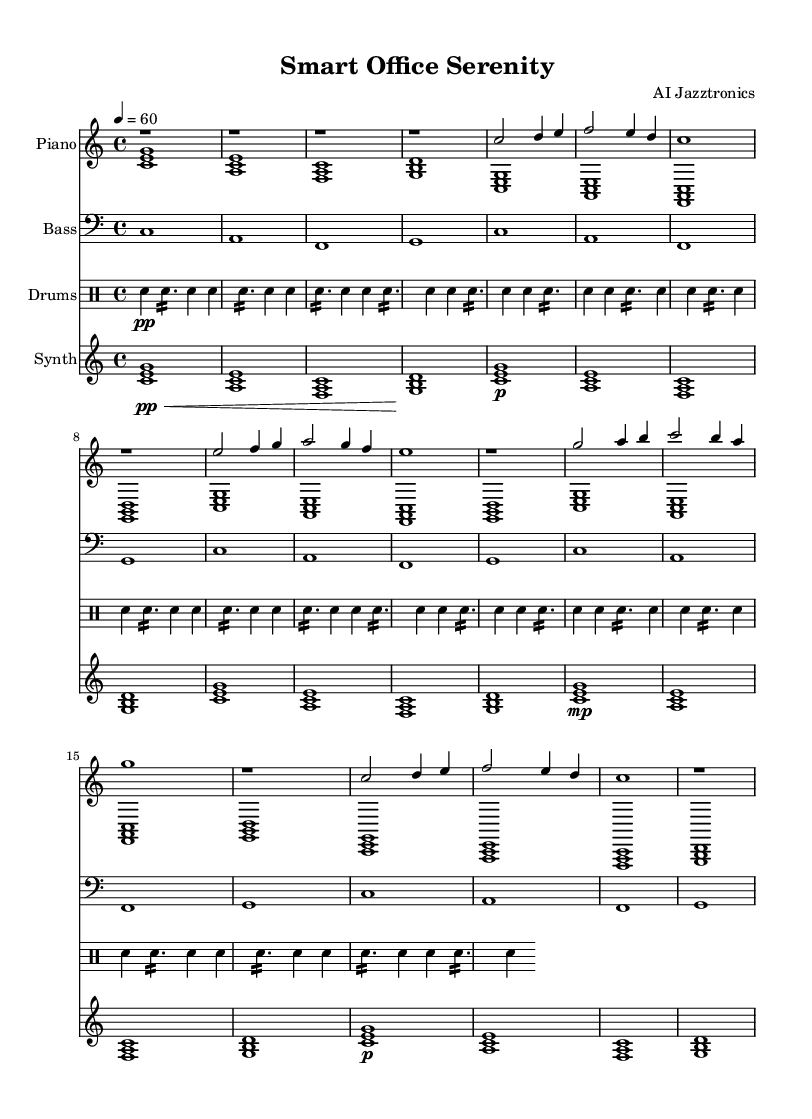What is the key signature of this music? The key signature is indicated by the absence of any sharps or flats at the beginning of the staff. Since it shows no alterations, it is in C major.
Answer: C major What is the time signature of the music? The time signature is shown at the beginning of the staff, where it indicates 4/4 time, meaning there are four beats per measure and the quarter note gets one beat.
Answer: 4/4 What is the tempo marking of the piece? The tempo marking is found in the 'global' music block where it states '4 = 60', meaning there are 60 beats per minute, and each beat is a quarter note.
Answer: 60 What is the structure of the piece in terms of sections? The structure outlined in the music comprises an 'Intro', 'Main Theme', 'Bridge', and 'Main Theme Variation,' as labeled within the score and organized in that order.
Answer: Intro, Main Theme, Bridge, Main Theme Variation How many measures are in the 'Main Theme' section? The 'Main Theme' section consists of two repetitions of the thematic material, totaling 8 measures labeled in the score (counting each measure individually as it appears).
Answer: 8 measures What is the role of the synth pad in the overall soundscape? The synth pad adds texture and ambiance to the piece. Its sustained chords provide a harmonic foundation and enhance the modern jazz sound characteristic of ambient soundscapes.
Answer: Harmonic foundation Which instrument plays the melody in the 'Main Theme'? The right hand of the piano plays the melody in the 'Main Theme' as indicated by the notes in the 'pianoRH' section of the sheet music.
Answer: Piano (right hand) 